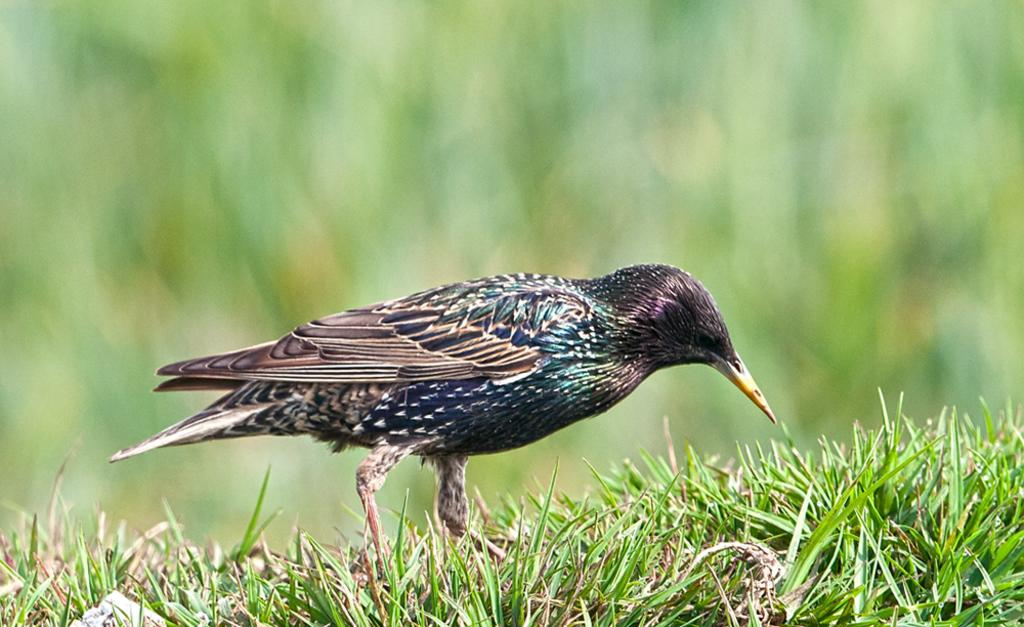What type of animal is in the image? There is a bird in the image. Where is the bird located? The bird is on the grass. Can you describe the background of the image? The background of the image is blurred. What type of lumber is being used to build the van in the image? There is no van or lumber present in the image; it features a bird on the grass with a blurred background. 